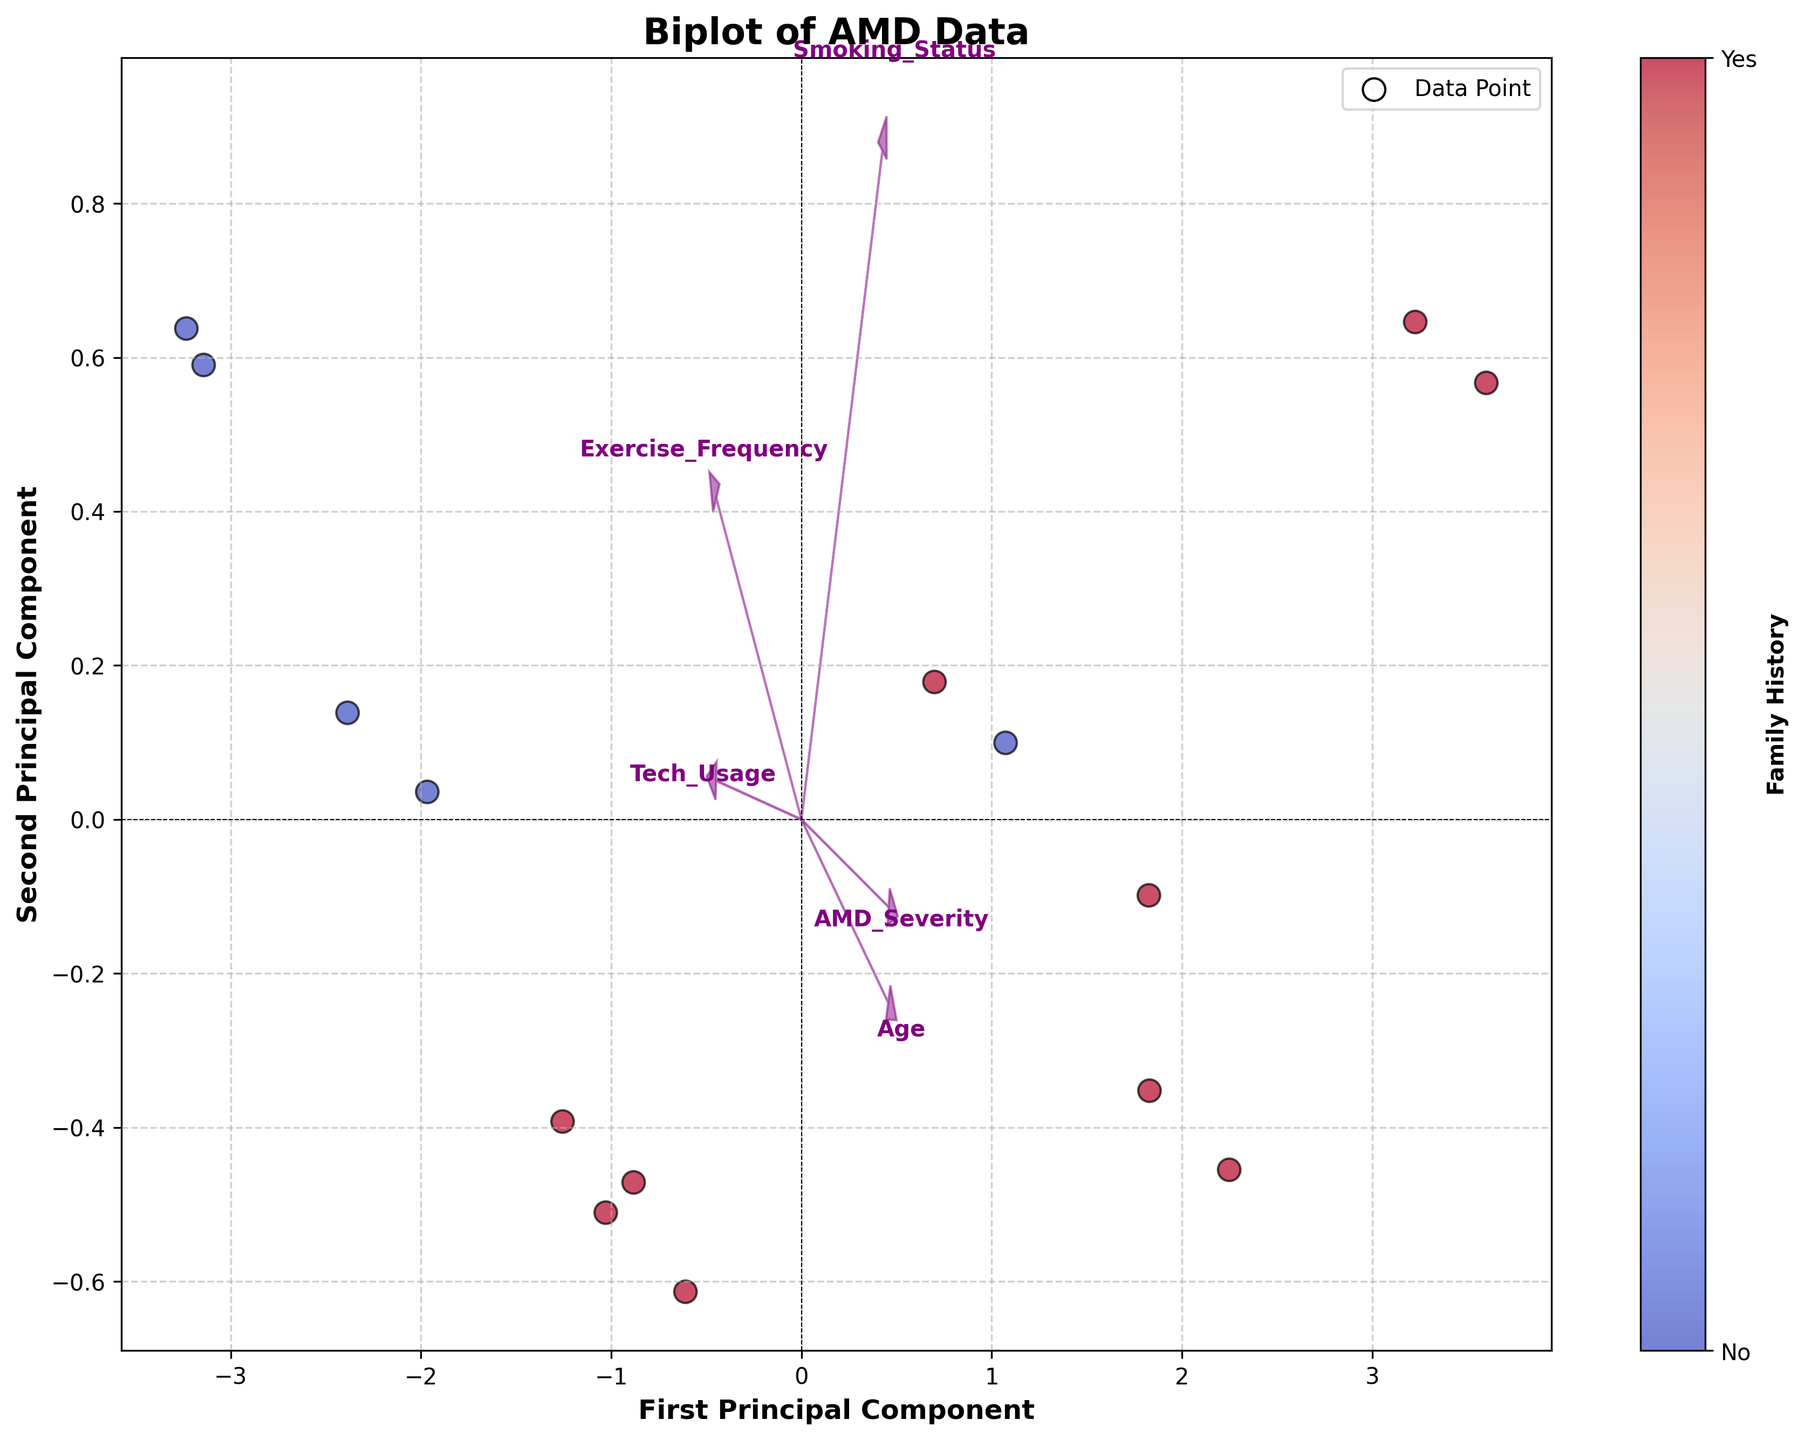What is the title of the biplot? The title of the plot is displayed at the top center of the figure. It reads, "Biplot of AMD Data".
Answer: Biplot of AMD Data How many data points are represented in the plot? Each data point is represented as a scatter point in the plot. By counting these scatter points, we find that there are 15 data points.
Answer: 15 Which principal component axis is associated with "Tech_Usage"? By looking at the arrows representing each feature, the "Tech_Usage" arrow is pointing in the direction of the First Principal Component axis.
Answer: First Principal Component Is there a clear separation between individuals with and without a family history of AMD on the biplot? By observing the color of the scatter points, individuals with a family history (red points) and without (blue points) do not have a clear separation in the principal component space. Both groups are fairly mixed throughout the plot.
Answer: No Which feature has the largest influence on the Second Principal Component? The influence of each feature on the principal components is depicted by the length of the arrows. The "Smoking_Status" arrow is the longest along the Second Principal Component axis, indicating it has the largest influence.
Answer: Smoking_Status What is the color representing individuals with a family history of AMD? The color map and the color bar on the right side of the plot indicate that individuals with a family history of AMD are represented in red.
Answer: Red Which age group has the highest AMD severity level? The arrow for "Age" is observed to check its direction and data points further in that direction are evaluated. The individual at age 80, indicated by the data point and direction, shows the highest AMD severity (value of 5).
Answer: Age 80 Do individuals with higher tech usage scores tend to cluster in any specific region of the plot? By examining data points' positions relative to the "Tech_Usage" arrow, the higher tech usage scores (~9) data points also scatter toward its direction, though they aren't strictly clustered there.
Answer: Tend to scatter but not strictly clustered Which two features are positioned closest to each other in the biplot? By examining the endpoint positions of the feature arrows, "Exercise_Frequency" and "Tech_Usage" show a proximity to each other than other features, indicating a similar directional influence.
Answer: Exercise_Frequency and Tech_Usage How would an increase in "Exercise_Frequency" impact the position on the First Principal Component axis? The arrow for "Exercise_Frequency" points in the positive direction along the First Principal Component axis, suggesting that an increase in exercise frequency would move a data point to the right.
Answer: Move to the right 